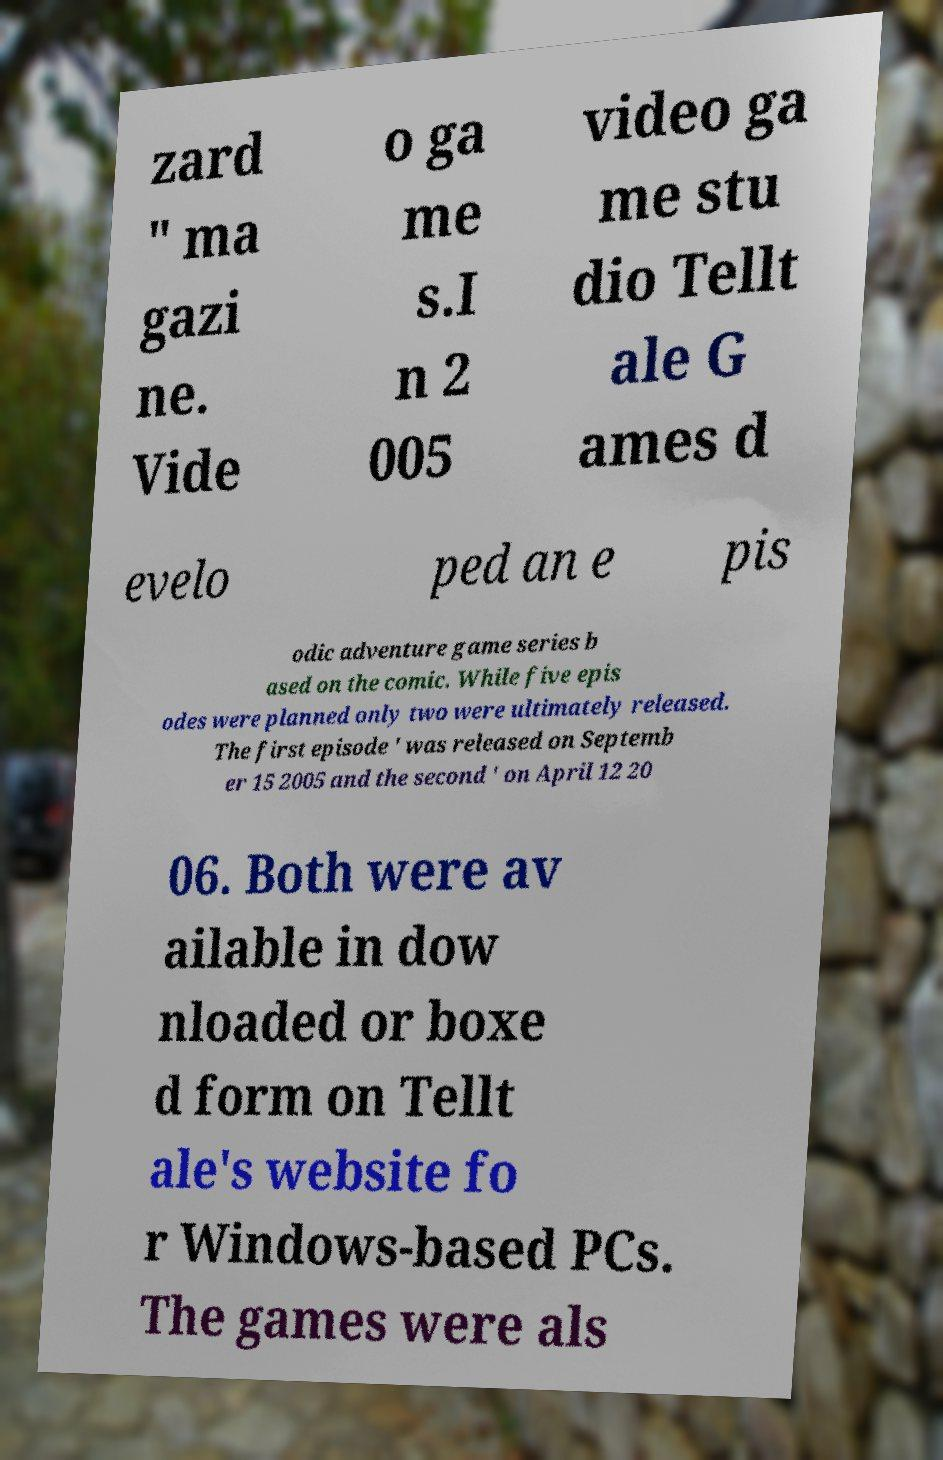I need the written content from this picture converted into text. Can you do that? zard " ma gazi ne. Vide o ga me s.I n 2 005 video ga me stu dio Tellt ale G ames d evelo ped an e pis odic adventure game series b ased on the comic. While five epis odes were planned only two were ultimately released. The first episode ' was released on Septemb er 15 2005 and the second ' on April 12 20 06. Both were av ailable in dow nloaded or boxe d form on Tellt ale's website fo r Windows-based PCs. The games were als 